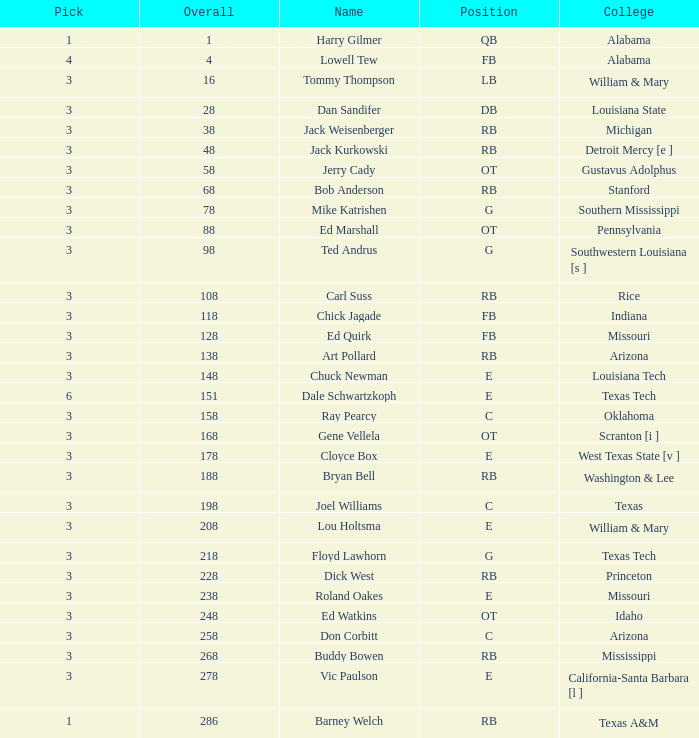How much aggregate has a name of bob anderson? 1.0. 